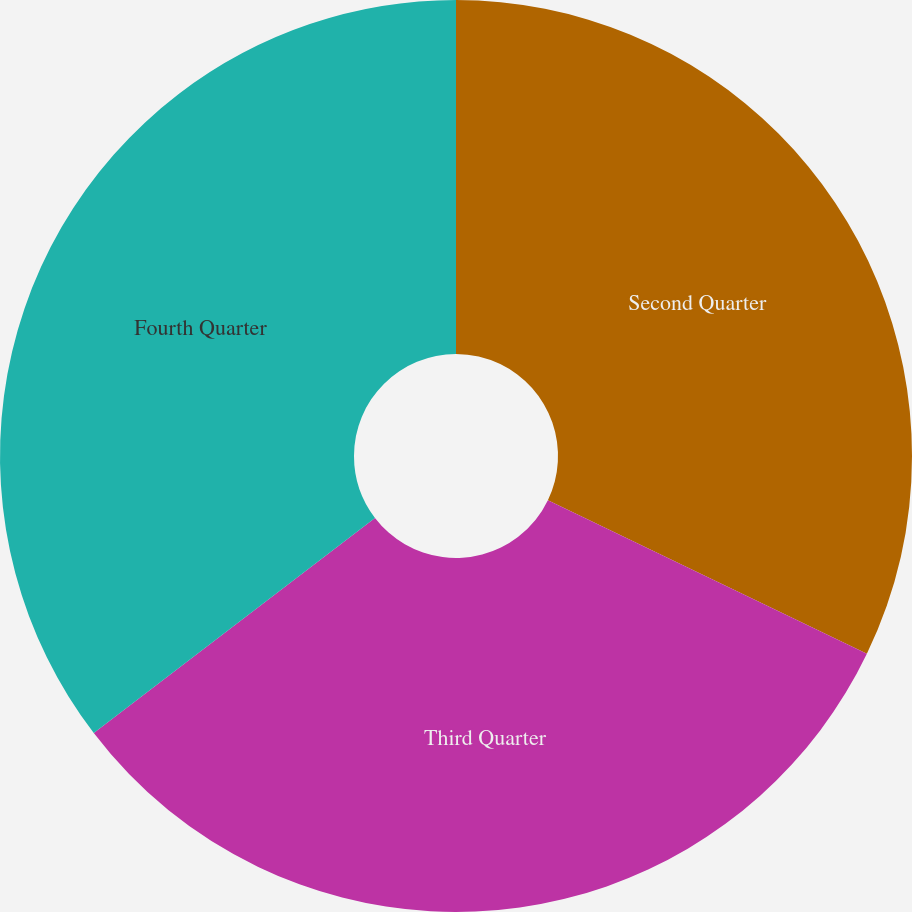<chart> <loc_0><loc_0><loc_500><loc_500><pie_chart><fcel>Second Quarter<fcel>Third Quarter<fcel>Fourth Quarter<nl><fcel>32.14%<fcel>32.47%<fcel>35.39%<nl></chart> 